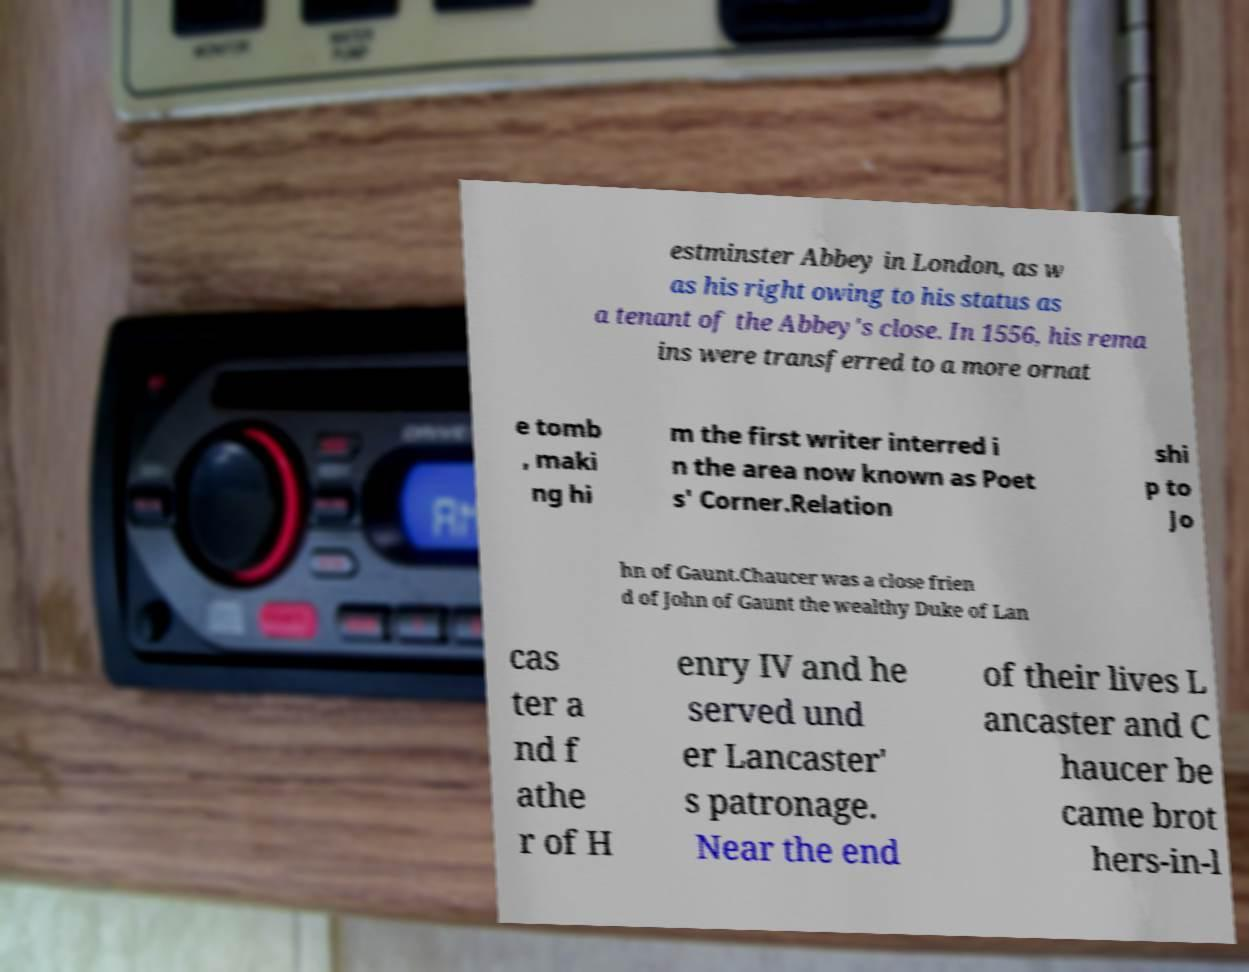I need the written content from this picture converted into text. Can you do that? estminster Abbey in London, as w as his right owing to his status as a tenant of the Abbey's close. In 1556, his rema ins were transferred to a more ornat e tomb , maki ng hi m the first writer interred i n the area now known as Poet s' Corner.Relation shi p to Jo hn of Gaunt.Chaucer was a close frien d of John of Gaunt the wealthy Duke of Lan cas ter a nd f athe r of H enry IV and he served und er Lancaster' s patronage. Near the end of their lives L ancaster and C haucer be came brot hers-in-l 